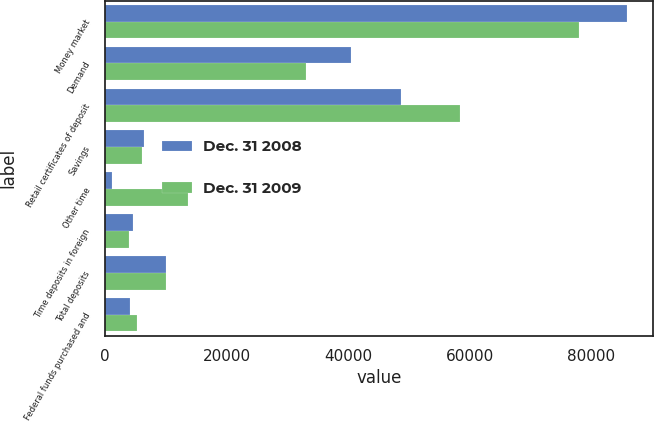<chart> <loc_0><loc_0><loc_500><loc_500><stacked_bar_chart><ecel><fcel>Money market<fcel>Demand<fcel>Retail certificates of deposit<fcel>Savings<fcel>Other time<fcel>Time deposits in foreign<fcel>Total deposits<fcel>Federal funds purchased and<nl><fcel>Dec. 31 2008<fcel>85838<fcel>40406<fcel>48622<fcel>6401<fcel>1088<fcel>4567<fcel>10010.5<fcel>3998<nl><fcel>Dec. 31 2009<fcel>77889<fcel>33001<fcel>58315<fcel>6056<fcel>13620<fcel>3984<fcel>10010.5<fcel>5153<nl></chart> 